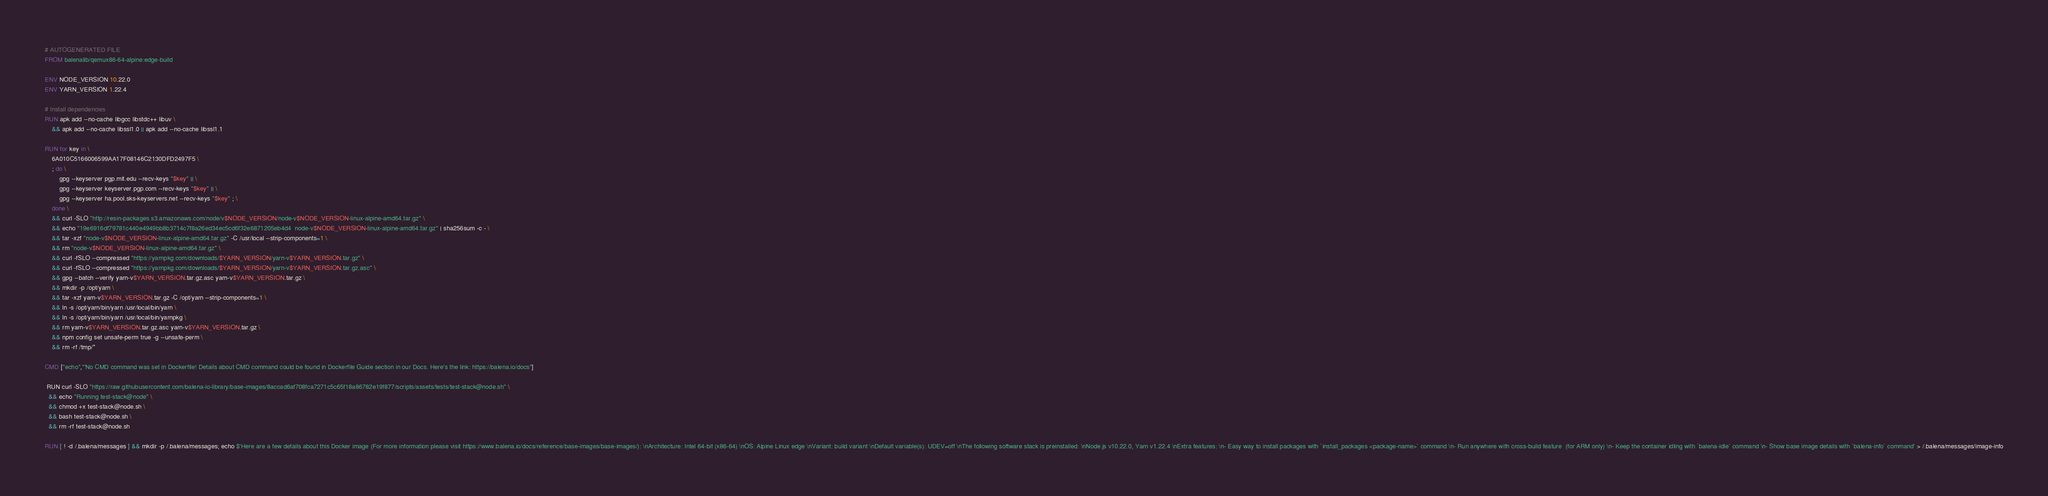<code> <loc_0><loc_0><loc_500><loc_500><_Dockerfile_># AUTOGENERATED FILE
FROM balenalib/qemux86-64-alpine:edge-build

ENV NODE_VERSION 10.22.0
ENV YARN_VERSION 1.22.4

# Install dependencies
RUN apk add --no-cache libgcc libstdc++ libuv \
	&& apk add --no-cache libssl1.0 || apk add --no-cache libssl1.1

RUN for key in \
	6A010C5166006599AA17F08146C2130DFD2497F5 \
	; do \
		gpg --keyserver pgp.mit.edu --recv-keys "$key" || \
		gpg --keyserver keyserver.pgp.com --recv-keys "$key" || \
		gpg --keyserver ha.pool.sks-keyservers.net --recv-keys "$key" ; \
	done \
	&& curl -SLO "http://resin-packages.s3.amazonaws.com/node/v$NODE_VERSION/node-v$NODE_VERSION-linux-alpine-amd64.tar.gz" \
	&& echo "19e6916df79781c440e4949bb8b3714c7f8a26ed34ec5cd6f32e6871205eb4d4  node-v$NODE_VERSION-linux-alpine-amd64.tar.gz" | sha256sum -c - \
	&& tar -xzf "node-v$NODE_VERSION-linux-alpine-amd64.tar.gz" -C /usr/local --strip-components=1 \
	&& rm "node-v$NODE_VERSION-linux-alpine-amd64.tar.gz" \
	&& curl -fSLO --compressed "https://yarnpkg.com/downloads/$YARN_VERSION/yarn-v$YARN_VERSION.tar.gz" \
	&& curl -fSLO --compressed "https://yarnpkg.com/downloads/$YARN_VERSION/yarn-v$YARN_VERSION.tar.gz.asc" \
	&& gpg --batch --verify yarn-v$YARN_VERSION.tar.gz.asc yarn-v$YARN_VERSION.tar.gz \
	&& mkdir -p /opt/yarn \
	&& tar -xzf yarn-v$YARN_VERSION.tar.gz -C /opt/yarn --strip-components=1 \
	&& ln -s /opt/yarn/bin/yarn /usr/local/bin/yarn \
	&& ln -s /opt/yarn/bin/yarn /usr/local/bin/yarnpkg \
	&& rm yarn-v$YARN_VERSION.tar.gz.asc yarn-v$YARN_VERSION.tar.gz \
	&& npm config set unsafe-perm true -g --unsafe-perm \
	&& rm -rf /tmp/*

CMD ["echo","'No CMD command was set in Dockerfile! Details about CMD command could be found in Dockerfile Guide section in our Docs. Here's the link: https://balena.io/docs"]

 RUN curl -SLO "https://raw.githubusercontent.com/balena-io-library/base-images/8accad6af708fca7271c5c65f18a86782e19f877/scripts/assets/tests/test-stack@node.sh" \
  && echo "Running test-stack@node" \
  && chmod +x test-stack@node.sh \
  && bash test-stack@node.sh \
  && rm -rf test-stack@node.sh 

RUN [ ! -d /.balena/messages ] && mkdir -p /.balena/messages; echo $'Here are a few details about this Docker image (For more information please visit https://www.balena.io/docs/reference/base-images/base-images/): \nArchitecture: Intel 64-bit (x86-64) \nOS: Alpine Linux edge \nVariant: build variant \nDefault variable(s): UDEV=off \nThe following software stack is preinstalled: \nNode.js v10.22.0, Yarn v1.22.4 \nExtra features: \n- Easy way to install packages with `install_packages <package-name>` command \n- Run anywhere with cross-build feature  (for ARM only) \n- Keep the container idling with `balena-idle` command \n- Show base image details with `balena-info` command' > /.balena/messages/image-info
</code> 